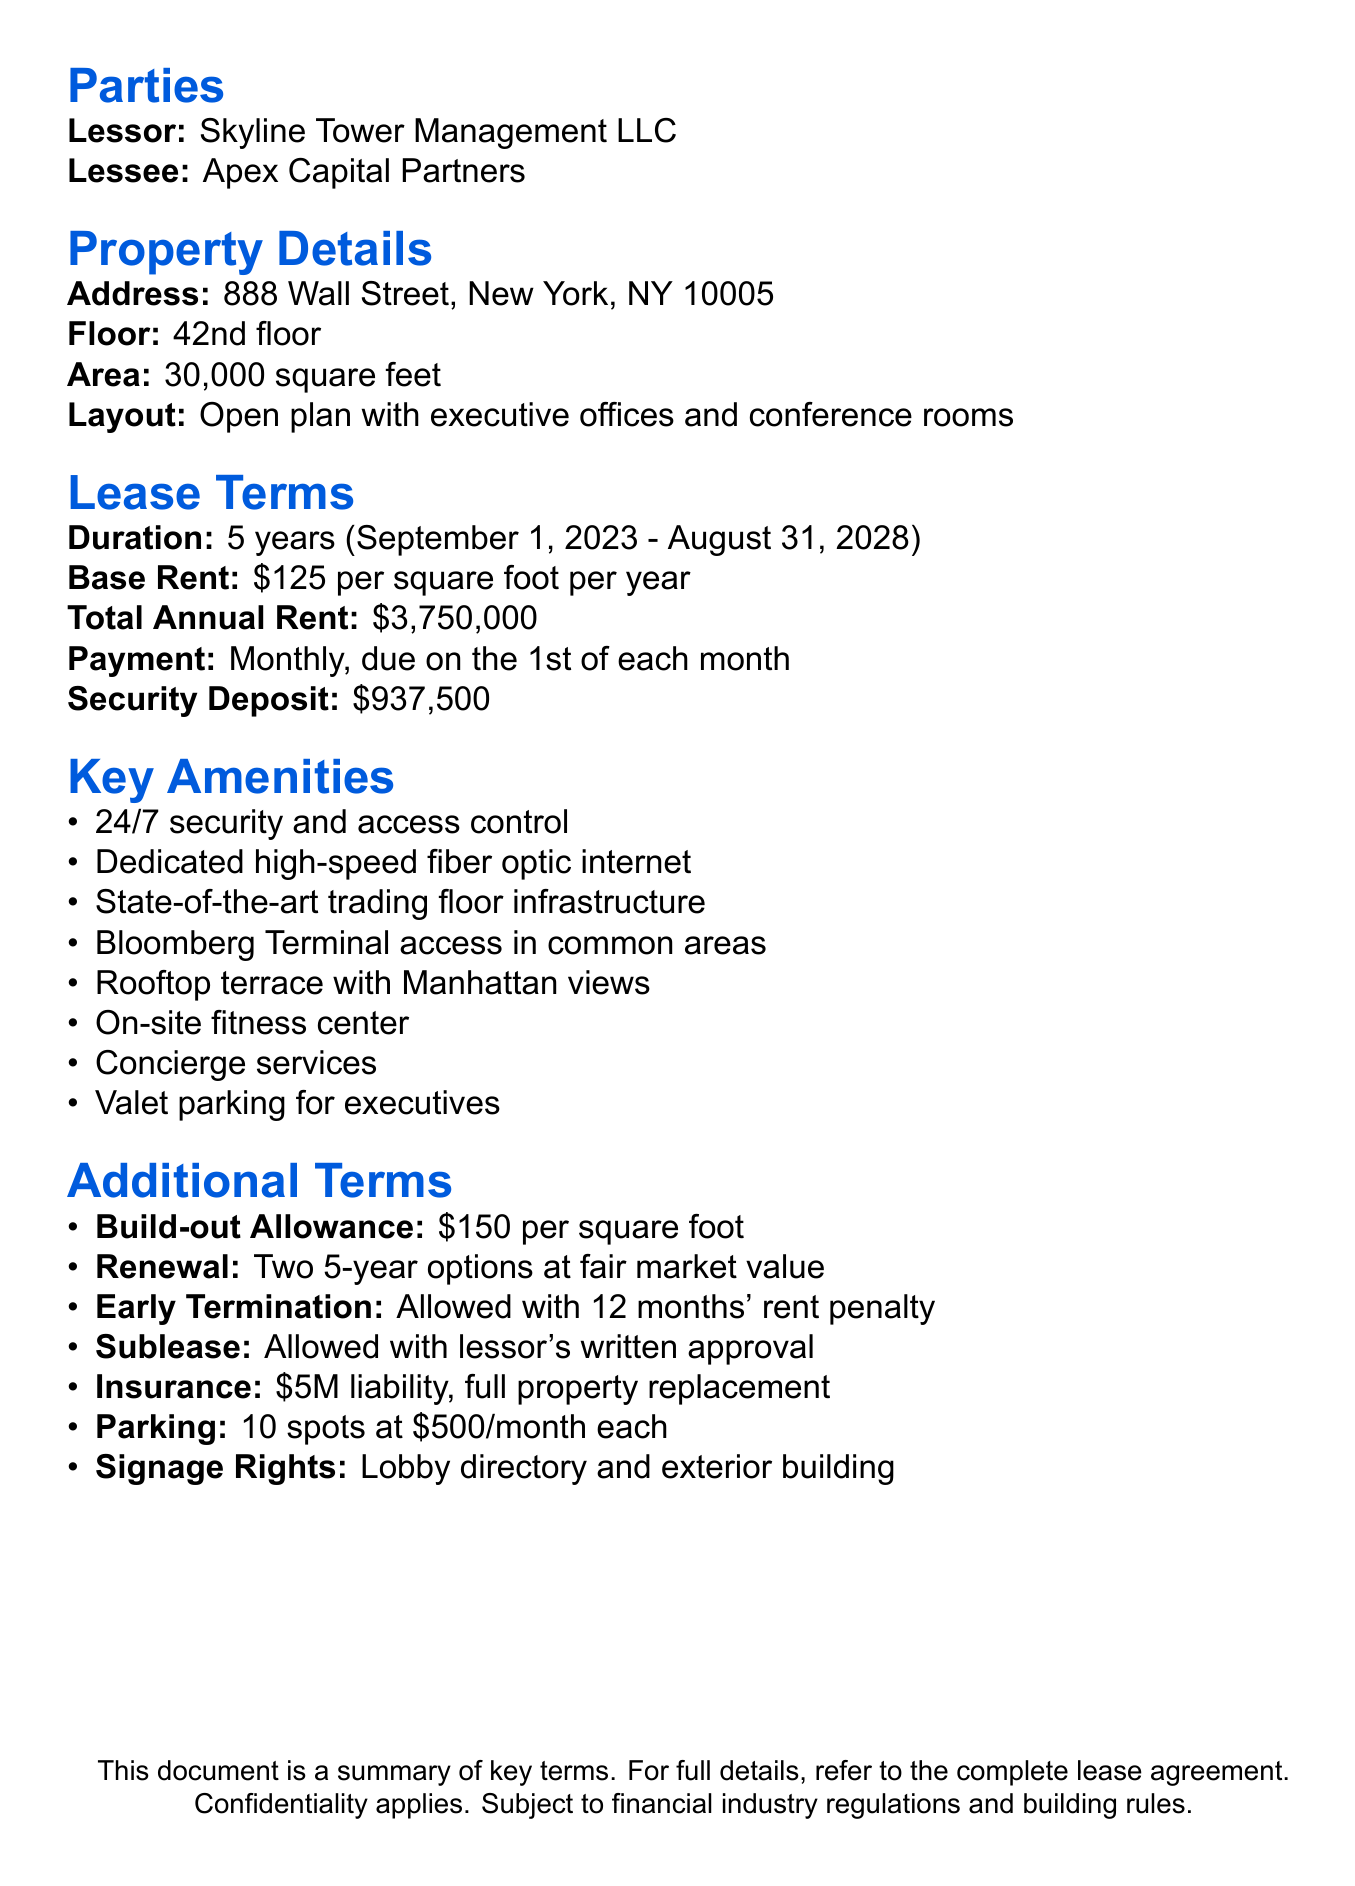What is the property address? The property address is specified in the document and is 888 Wall Street, New York, NY 10005.
Answer: 888 Wall Street, New York, NY 10005 What are the lease terms duration? The lease term duration is stated in the document, covering a period of 5 years.
Answer: 5 years When does the lease start? The start date of the lease is explicitly mentioned in the document as September 1, 2023.
Answer: September 1, 2023 What is the base rent per square foot? The base rent is detailed in the document as $125 per square foot per year.
Answer: $125 per square foot per year How many allocated parking spots are there? The document indicates that there are a total of 10 allocated parking spots for the lessee.
Answer: 10 What amenities include 24/7 security? The document lists "24/7 security and access control" as one of the provided amenities.
Answer: 24/7 security and access control What is the penalty for early termination? The early termination penalty is stated in the document as 12 months' rent plus unamortized tenant improvements.
Answer: 12 months' rent plus unamortized tenant improvements Is subleasing allowed? The terms regarding subleasing are explicitly mentioned in the document and indicate that it is allowed.
Answer: Allowed What is the insurance requirement for commercial general liability? According to the document, the insurance requirement is $5,000,000 per occurrence.
Answer: $5,000,000 per occurrence 